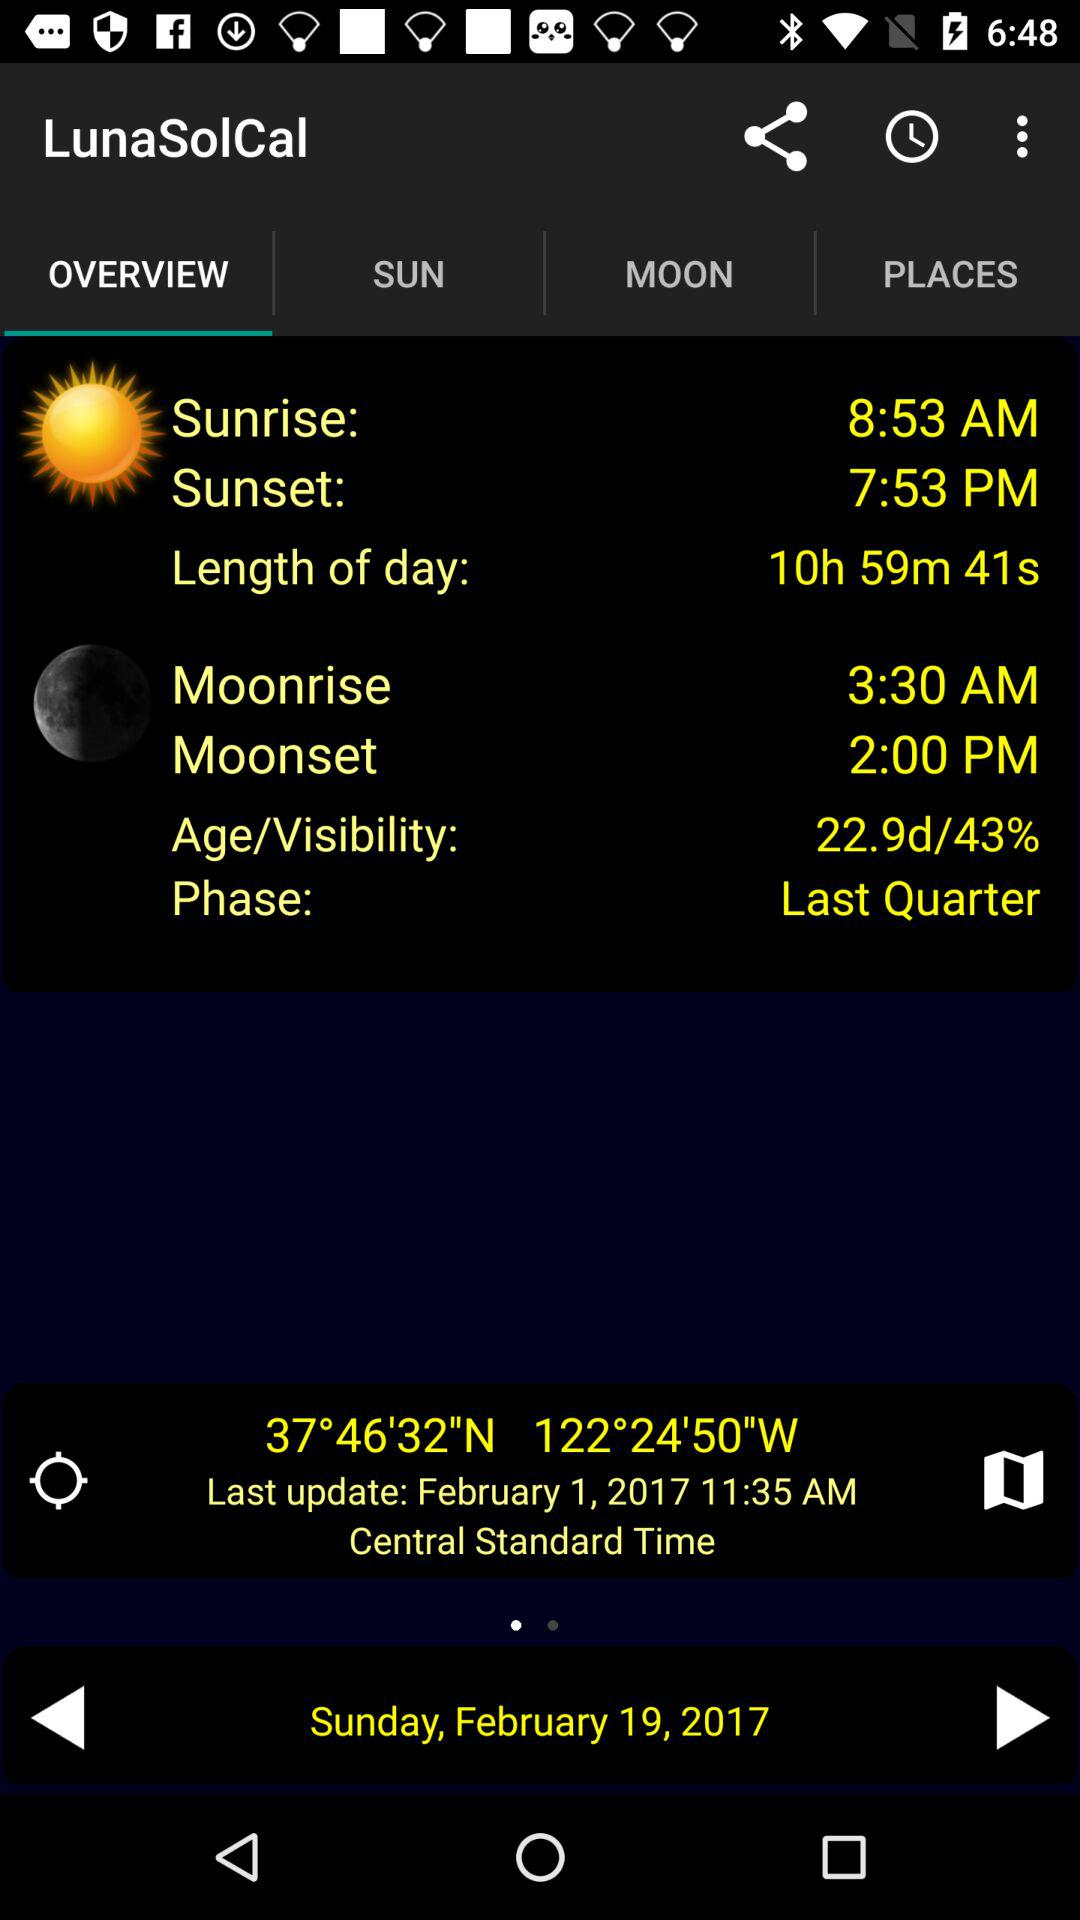What's the "Age/Visibility"? The "Age/Visibility" is 22.9d/43%. 